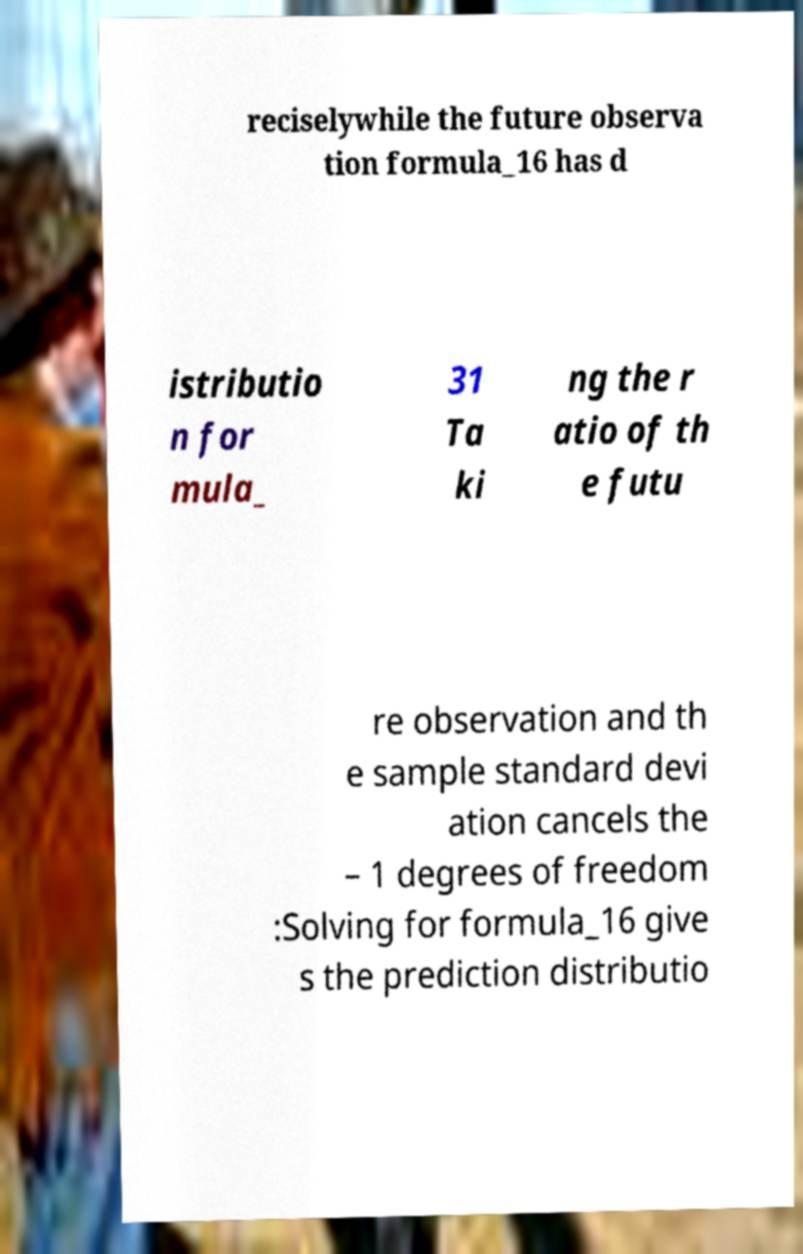What messages or text are displayed in this image? I need them in a readable, typed format. reciselywhile the future observa tion formula_16 has d istributio n for mula_ 31 Ta ki ng the r atio of th e futu re observation and th e sample standard devi ation cancels the – 1 degrees of freedom :Solving for formula_16 give s the prediction distributio 